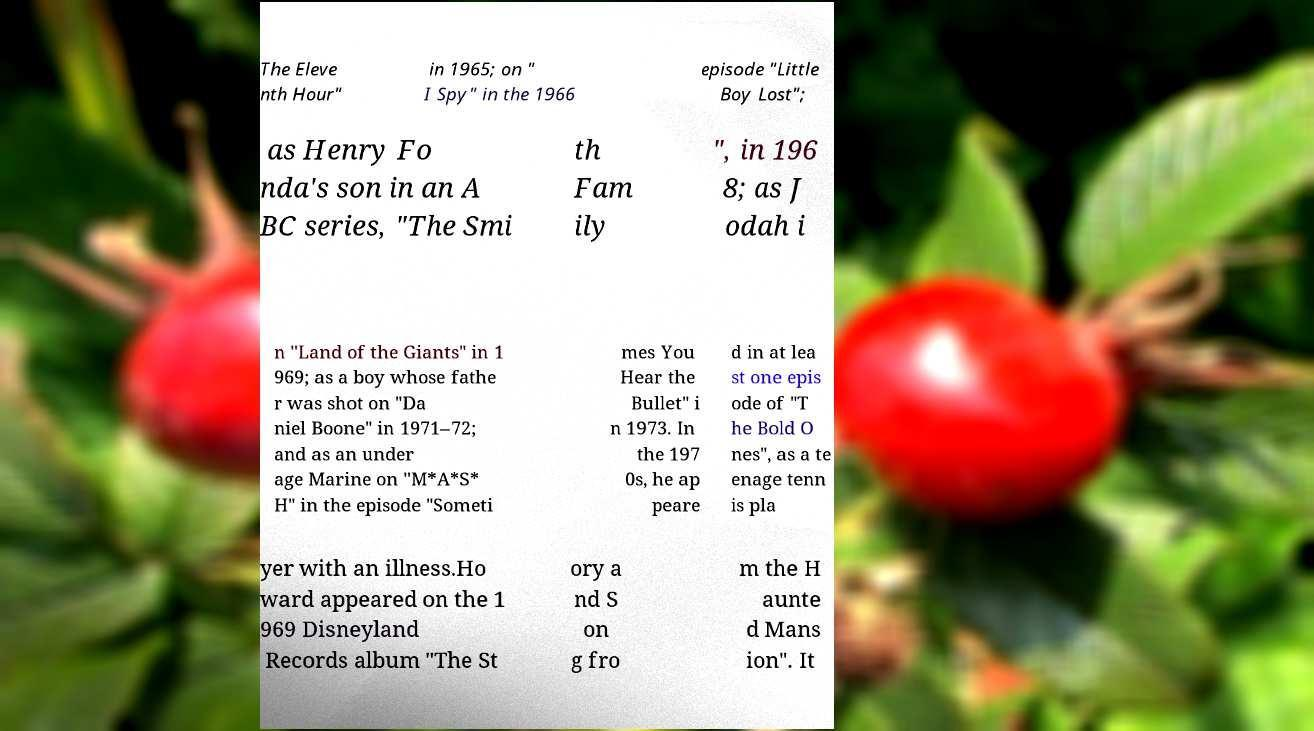I need the written content from this picture converted into text. Can you do that? The Eleve nth Hour" in 1965; on " I Spy" in the 1966 episode "Little Boy Lost"; as Henry Fo nda's son in an A BC series, "The Smi th Fam ily ", in 196 8; as J odah i n "Land of the Giants" in 1 969; as a boy whose fathe r was shot on "Da niel Boone" in 1971–72; and as an under age Marine on "M*A*S* H" in the episode "Someti mes You Hear the Bullet" i n 1973. In the 197 0s, he ap peare d in at lea st one epis ode of "T he Bold O nes", as a te enage tenn is pla yer with an illness.Ho ward appeared on the 1 969 Disneyland Records album "The St ory a nd S on g fro m the H aunte d Mans ion". It 